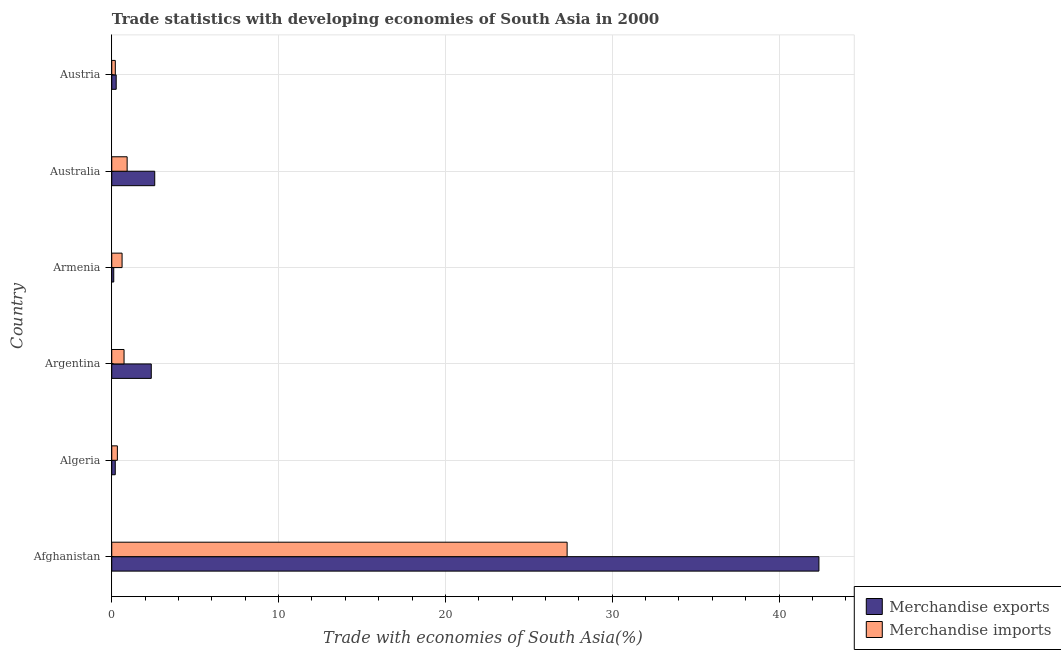How many bars are there on the 1st tick from the top?
Your response must be concise. 2. How many bars are there on the 1st tick from the bottom?
Offer a terse response. 2. What is the label of the 4th group of bars from the top?
Give a very brief answer. Argentina. In how many cases, is the number of bars for a given country not equal to the number of legend labels?
Provide a short and direct response. 0. What is the merchandise imports in Algeria?
Your answer should be compact. 0.34. Across all countries, what is the maximum merchandise imports?
Offer a terse response. 27.3. Across all countries, what is the minimum merchandise imports?
Provide a succinct answer. 0.21. In which country was the merchandise imports maximum?
Offer a terse response. Afghanistan. In which country was the merchandise exports minimum?
Offer a very short reply. Armenia. What is the total merchandise exports in the graph?
Make the answer very short. 47.94. What is the difference between the merchandise exports in Afghanistan and that in Austria?
Offer a terse response. 42.12. What is the difference between the merchandise imports in Australia and the merchandise exports in Austria?
Provide a short and direct response. 0.66. What is the average merchandise imports per country?
Offer a terse response. 5.02. What is the difference between the merchandise imports and merchandise exports in Australia?
Provide a short and direct response. -1.65. In how many countries, is the merchandise imports greater than 40 %?
Provide a short and direct response. 0. What is the ratio of the merchandise imports in Afghanistan to that in Armenia?
Give a very brief answer. 44.11. Is the merchandise exports in Afghanistan less than that in Austria?
Your response must be concise. No. What is the difference between the highest and the second highest merchandise imports?
Offer a terse response. 26.38. What is the difference between the highest and the lowest merchandise exports?
Provide a short and direct response. 42.27. In how many countries, is the merchandise exports greater than the average merchandise exports taken over all countries?
Keep it short and to the point. 1. Is the sum of the merchandise exports in Algeria and Argentina greater than the maximum merchandise imports across all countries?
Offer a terse response. No. What does the 1st bar from the top in Algeria represents?
Your answer should be compact. Merchandise imports. What does the 1st bar from the bottom in Austria represents?
Ensure brevity in your answer.  Merchandise exports. How many bars are there?
Your answer should be very brief. 12. Are all the bars in the graph horizontal?
Offer a very short reply. Yes. What is the difference between two consecutive major ticks on the X-axis?
Your response must be concise. 10. Are the values on the major ticks of X-axis written in scientific E-notation?
Your answer should be very brief. No. Does the graph contain any zero values?
Give a very brief answer. No. Does the graph contain grids?
Provide a succinct answer. Yes. Where does the legend appear in the graph?
Keep it short and to the point. Bottom right. What is the title of the graph?
Your response must be concise. Trade statistics with developing economies of South Asia in 2000. What is the label or title of the X-axis?
Your response must be concise. Trade with economies of South Asia(%). What is the Trade with economies of South Asia(%) in Merchandise exports in Afghanistan?
Provide a short and direct response. 42.39. What is the Trade with economies of South Asia(%) in Merchandise imports in Afghanistan?
Your answer should be compact. 27.3. What is the Trade with economies of South Asia(%) in Merchandise exports in Algeria?
Offer a terse response. 0.21. What is the Trade with economies of South Asia(%) of Merchandise imports in Algeria?
Offer a terse response. 0.34. What is the Trade with economies of South Asia(%) of Merchandise exports in Argentina?
Make the answer very short. 2.37. What is the Trade with economies of South Asia(%) of Merchandise imports in Argentina?
Your response must be concise. 0.74. What is the Trade with economies of South Asia(%) of Merchandise exports in Armenia?
Your response must be concise. 0.12. What is the Trade with economies of South Asia(%) of Merchandise imports in Armenia?
Keep it short and to the point. 0.62. What is the Trade with economies of South Asia(%) of Merchandise exports in Australia?
Ensure brevity in your answer.  2.58. What is the Trade with economies of South Asia(%) of Merchandise imports in Australia?
Provide a succinct answer. 0.92. What is the Trade with economies of South Asia(%) of Merchandise exports in Austria?
Make the answer very short. 0.27. What is the Trade with economies of South Asia(%) in Merchandise imports in Austria?
Your answer should be very brief. 0.21. Across all countries, what is the maximum Trade with economies of South Asia(%) of Merchandise exports?
Give a very brief answer. 42.39. Across all countries, what is the maximum Trade with economies of South Asia(%) in Merchandise imports?
Your answer should be very brief. 27.3. Across all countries, what is the minimum Trade with economies of South Asia(%) of Merchandise exports?
Your response must be concise. 0.12. Across all countries, what is the minimum Trade with economies of South Asia(%) in Merchandise imports?
Keep it short and to the point. 0.21. What is the total Trade with economies of South Asia(%) of Merchandise exports in the graph?
Your response must be concise. 47.94. What is the total Trade with economies of South Asia(%) in Merchandise imports in the graph?
Provide a succinct answer. 30.13. What is the difference between the Trade with economies of South Asia(%) of Merchandise exports in Afghanistan and that in Algeria?
Keep it short and to the point. 42.18. What is the difference between the Trade with economies of South Asia(%) in Merchandise imports in Afghanistan and that in Algeria?
Provide a short and direct response. 26.96. What is the difference between the Trade with economies of South Asia(%) in Merchandise exports in Afghanistan and that in Argentina?
Your answer should be very brief. 40.02. What is the difference between the Trade with economies of South Asia(%) in Merchandise imports in Afghanistan and that in Argentina?
Your answer should be very brief. 26.56. What is the difference between the Trade with economies of South Asia(%) in Merchandise exports in Afghanistan and that in Armenia?
Provide a short and direct response. 42.27. What is the difference between the Trade with economies of South Asia(%) of Merchandise imports in Afghanistan and that in Armenia?
Offer a terse response. 26.68. What is the difference between the Trade with economies of South Asia(%) of Merchandise exports in Afghanistan and that in Australia?
Offer a terse response. 39.81. What is the difference between the Trade with economies of South Asia(%) in Merchandise imports in Afghanistan and that in Australia?
Your response must be concise. 26.38. What is the difference between the Trade with economies of South Asia(%) in Merchandise exports in Afghanistan and that in Austria?
Your answer should be very brief. 42.12. What is the difference between the Trade with economies of South Asia(%) in Merchandise imports in Afghanistan and that in Austria?
Provide a short and direct response. 27.08. What is the difference between the Trade with economies of South Asia(%) of Merchandise exports in Algeria and that in Argentina?
Your response must be concise. -2.16. What is the difference between the Trade with economies of South Asia(%) of Merchandise imports in Algeria and that in Argentina?
Give a very brief answer. -0.4. What is the difference between the Trade with economies of South Asia(%) of Merchandise exports in Algeria and that in Armenia?
Keep it short and to the point. 0.09. What is the difference between the Trade with economies of South Asia(%) of Merchandise imports in Algeria and that in Armenia?
Your answer should be compact. -0.28. What is the difference between the Trade with economies of South Asia(%) of Merchandise exports in Algeria and that in Australia?
Offer a very short reply. -2.37. What is the difference between the Trade with economies of South Asia(%) in Merchandise imports in Algeria and that in Australia?
Ensure brevity in your answer.  -0.58. What is the difference between the Trade with economies of South Asia(%) of Merchandise exports in Algeria and that in Austria?
Offer a very short reply. -0.06. What is the difference between the Trade with economies of South Asia(%) of Merchandise imports in Algeria and that in Austria?
Offer a terse response. 0.12. What is the difference between the Trade with economies of South Asia(%) in Merchandise exports in Argentina and that in Armenia?
Your answer should be compact. 2.25. What is the difference between the Trade with economies of South Asia(%) of Merchandise imports in Argentina and that in Armenia?
Keep it short and to the point. 0.12. What is the difference between the Trade with economies of South Asia(%) of Merchandise exports in Argentina and that in Australia?
Ensure brevity in your answer.  -0.21. What is the difference between the Trade with economies of South Asia(%) in Merchandise imports in Argentina and that in Australia?
Offer a very short reply. -0.18. What is the difference between the Trade with economies of South Asia(%) of Merchandise exports in Argentina and that in Austria?
Your answer should be compact. 2.1. What is the difference between the Trade with economies of South Asia(%) of Merchandise imports in Argentina and that in Austria?
Provide a short and direct response. 0.52. What is the difference between the Trade with economies of South Asia(%) of Merchandise exports in Armenia and that in Australia?
Offer a terse response. -2.46. What is the difference between the Trade with economies of South Asia(%) in Merchandise imports in Armenia and that in Australia?
Make the answer very short. -0.3. What is the difference between the Trade with economies of South Asia(%) in Merchandise exports in Armenia and that in Austria?
Make the answer very short. -0.15. What is the difference between the Trade with economies of South Asia(%) of Merchandise imports in Armenia and that in Austria?
Provide a succinct answer. 0.4. What is the difference between the Trade with economies of South Asia(%) of Merchandise exports in Australia and that in Austria?
Your answer should be compact. 2.31. What is the difference between the Trade with economies of South Asia(%) of Merchandise imports in Australia and that in Austria?
Your answer should be very brief. 0.71. What is the difference between the Trade with economies of South Asia(%) of Merchandise exports in Afghanistan and the Trade with economies of South Asia(%) of Merchandise imports in Algeria?
Offer a terse response. 42.05. What is the difference between the Trade with economies of South Asia(%) of Merchandise exports in Afghanistan and the Trade with economies of South Asia(%) of Merchandise imports in Argentina?
Provide a short and direct response. 41.65. What is the difference between the Trade with economies of South Asia(%) in Merchandise exports in Afghanistan and the Trade with economies of South Asia(%) in Merchandise imports in Armenia?
Give a very brief answer. 41.77. What is the difference between the Trade with economies of South Asia(%) of Merchandise exports in Afghanistan and the Trade with economies of South Asia(%) of Merchandise imports in Australia?
Your answer should be very brief. 41.47. What is the difference between the Trade with economies of South Asia(%) in Merchandise exports in Afghanistan and the Trade with economies of South Asia(%) in Merchandise imports in Austria?
Provide a succinct answer. 42.18. What is the difference between the Trade with economies of South Asia(%) in Merchandise exports in Algeria and the Trade with economies of South Asia(%) in Merchandise imports in Argentina?
Offer a very short reply. -0.53. What is the difference between the Trade with economies of South Asia(%) in Merchandise exports in Algeria and the Trade with economies of South Asia(%) in Merchandise imports in Armenia?
Provide a succinct answer. -0.41. What is the difference between the Trade with economies of South Asia(%) of Merchandise exports in Algeria and the Trade with economies of South Asia(%) of Merchandise imports in Australia?
Offer a terse response. -0.71. What is the difference between the Trade with economies of South Asia(%) in Merchandise exports in Algeria and the Trade with economies of South Asia(%) in Merchandise imports in Austria?
Your response must be concise. -0. What is the difference between the Trade with economies of South Asia(%) of Merchandise exports in Argentina and the Trade with economies of South Asia(%) of Merchandise imports in Armenia?
Your answer should be very brief. 1.75. What is the difference between the Trade with economies of South Asia(%) of Merchandise exports in Argentina and the Trade with economies of South Asia(%) of Merchandise imports in Australia?
Ensure brevity in your answer.  1.45. What is the difference between the Trade with economies of South Asia(%) of Merchandise exports in Argentina and the Trade with economies of South Asia(%) of Merchandise imports in Austria?
Your response must be concise. 2.16. What is the difference between the Trade with economies of South Asia(%) in Merchandise exports in Armenia and the Trade with economies of South Asia(%) in Merchandise imports in Australia?
Provide a succinct answer. -0.8. What is the difference between the Trade with economies of South Asia(%) of Merchandise exports in Armenia and the Trade with economies of South Asia(%) of Merchandise imports in Austria?
Offer a very short reply. -0.09. What is the difference between the Trade with economies of South Asia(%) of Merchandise exports in Australia and the Trade with economies of South Asia(%) of Merchandise imports in Austria?
Your answer should be compact. 2.36. What is the average Trade with economies of South Asia(%) in Merchandise exports per country?
Make the answer very short. 7.99. What is the average Trade with economies of South Asia(%) in Merchandise imports per country?
Your answer should be very brief. 5.02. What is the difference between the Trade with economies of South Asia(%) in Merchandise exports and Trade with economies of South Asia(%) in Merchandise imports in Afghanistan?
Provide a short and direct response. 15.09. What is the difference between the Trade with economies of South Asia(%) in Merchandise exports and Trade with economies of South Asia(%) in Merchandise imports in Algeria?
Provide a succinct answer. -0.13. What is the difference between the Trade with economies of South Asia(%) in Merchandise exports and Trade with economies of South Asia(%) in Merchandise imports in Argentina?
Ensure brevity in your answer.  1.63. What is the difference between the Trade with economies of South Asia(%) in Merchandise exports and Trade with economies of South Asia(%) in Merchandise imports in Armenia?
Your answer should be compact. -0.5. What is the difference between the Trade with economies of South Asia(%) of Merchandise exports and Trade with economies of South Asia(%) of Merchandise imports in Australia?
Give a very brief answer. 1.65. What is the difference between the Trade with economies of South Asia(%) of Merchandise exports and Trade with economies of South Asia(%) of Merchandise imports in Austria?
Provide a short and direct response. 0.05. What is the ratio of the Trade with economies of South Asia(%) of Merchandise exports in Afghanistan to that in Algeria?
Offer a terse response. 200.71. What is the ratio of the Trade with economies of South Asia(%) of Merchandise imports in Afghanistan to that in Algeria?
Your answer should be compact. 80.86. What is the ratio of the Trade with economies of South Asia(%) of Merchandise exports in Afghanistan to that in Argentina?
Ensure brevity in your answer.  17.89. What is the ratio of the Trade with economies of South Asia(%) of Merchandise imports in Afghanistan to that in Argentina?
Make the answer very short. 37. What is the ratio of the Trade with economies of South Asia(%) in Merchandise exports in Afghanistan to that in Armenia?
Your answer should be very brief. 352.66. What is the ratio of the Trade with economies of South Asia(%) in Merchandise imports in Afghanistan to that in Armenia?
Your answer should be compact. 44.11. What is the ratio of the Trade with economies of South Asia(%) of Merchandise exports in Afghanistan to that in Australia?
Provide a succinct answer. 16.45. What is the ratio of the Trade with economies of South Asia(%) of Merchandise imports in Afghanistan to that in Australia?
Offer a very short reply. 29.59. What is the ratio of the Trade with economies of South Asia(%) in Merchandise exports in Afghanistan to that in Austria?
Ensure brevity in your answer.  158.74. What is the ratio of the Trade with economies of South Asia(%) of Merchandise imports in Afghanistan to that in Austria?
Give a very brief answer. 127.55. What is the ratio of the Trade with economies of South Asia(%) of Merchandise exports in Algeria to that in Argentina?
Provide a succinct answer. 0.09. What is the ratio of the Trade with economies of South Asia(%) in Merchandise imports in Algeria to that in Argentina?
Your response must be concise. 0.46. What is the ratio of the Trade with economies of South Asia(%) of Merchandise exports in Algeria to that in Armenia?
Your response must be concise. 1.76. What is the ratio of the Trade with economies of South Asia(%) in Merchandise imports in Algeria to that in Armenia?
Keep it short and to the point. 0.55. What is the ratio of the Trade with economies of South Asia(%) in Merchandise exports in Algeria to that in Australia?
Keep it short and to the point. 0.08. What is the ratio of the Trade with economies of South Asia(%) in Merchandise imports in Algeria to that in Australia?
Ensure brevity in your answer.  0.37. What is the ratio of the Trade with economies of South Asia(%) of Merchandise exports in Algeria to that in Austria?
Your response must be concise. 0.79. What is the ratio of the Trade with economies of South Asia(%) in Merchandise imports in Algeria to that in Austria?
Your response must be concise. 1.58. What is the ratio of the Trade with economies of South Asia(%) in Merchandise exports in Argentina to that in Armenia?
Your answer should be compact. 19.72. What is the ratio of the Trade with economies of South Asia(%) of Merchandise imports in Argentina to that in Armenia?
Provide a succinct answer. 1.19. What is the ratio of the Trade with economies of South Asia(%) of Merchandise exports in Argentina to that in Australia?
Provide a succinct answer. 0.92. What is the ratio of the Trade with economies of South Asia(%) of Merchandise imports in Argentina to that in Australia?
Your response must be concise. 0.8. What is the ratio of the Trade with economies of South Asia(%) in Merchandise exports in Argentina to that in Austria?
Offer a terse response. 8.87. What is the ratio of the Trade with economies of South Asia(%) of Merchandise imports in Argentina to that in Austria?
Provide a short and direct response. 3.45. What is the ratio of the Trade with economies of South Asia(%) in Merchandise exports in Armenia to that in Australia?
Offer a very short reply. 0.05. What is the ratio of the Trade with economies of South Asia(%) of Merchandise imports in Armenia to that in Australia?
Provide a short and direct response. 0.67. What is the ratio of the Trade with economies of South Asia(%) in Merchandise exports in Armenia to that in Austria?
Provide a succinct answer. 0.45. What is the ratio of the Trade with economies of South Asia(%) in Merchandise imports in Armenia to that in Austria?
Provide a short and direct response. 2.89. What is the ratio of the Trade with economies of South Asia(%) in Merchandise exports in Australia to that in Austria?
Make the answer very short. 9.65. What is the ratio of the Trade with economies of South Asia(%) in Merchandise imports in Australia to that in Austria?
Keep it short and to the point. 4.31. What is the difference between the highest and the second highest Trade with economies of South Asia(%) of Merchandise exports?
Offer a very short reply. 39.81. What is the difference between the highest and the second highest Trade with economies of South Asia(%) of Merchandise imports?
Your answer should be compact. 26.38. What is the difference between the highest and the lowest Trade with economies of South Asia(%) in Merchandise exports?
Give a very brief answer. 42.27. What is the difference between the highest and the lowest Trade with economies of South Asia(%) in Merchandise imports?
Keep it short and to the point. 27.08. 